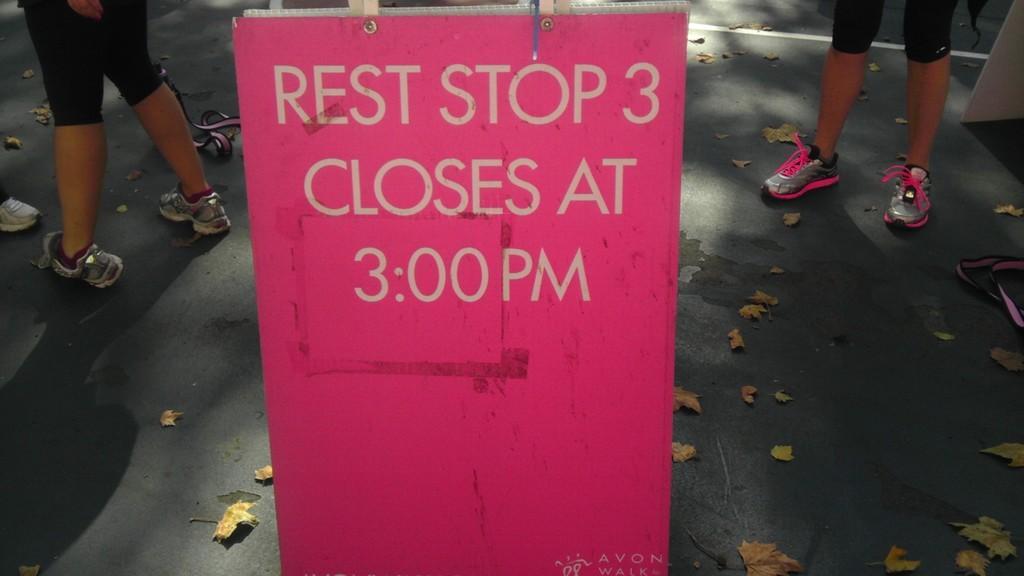Can you describe this image briefly? In the middle it's a board which is in pink color, in the left side there is a human standing, this person wore a black color short. In the right side there is another human standing, this person wore a pink color shoes. 